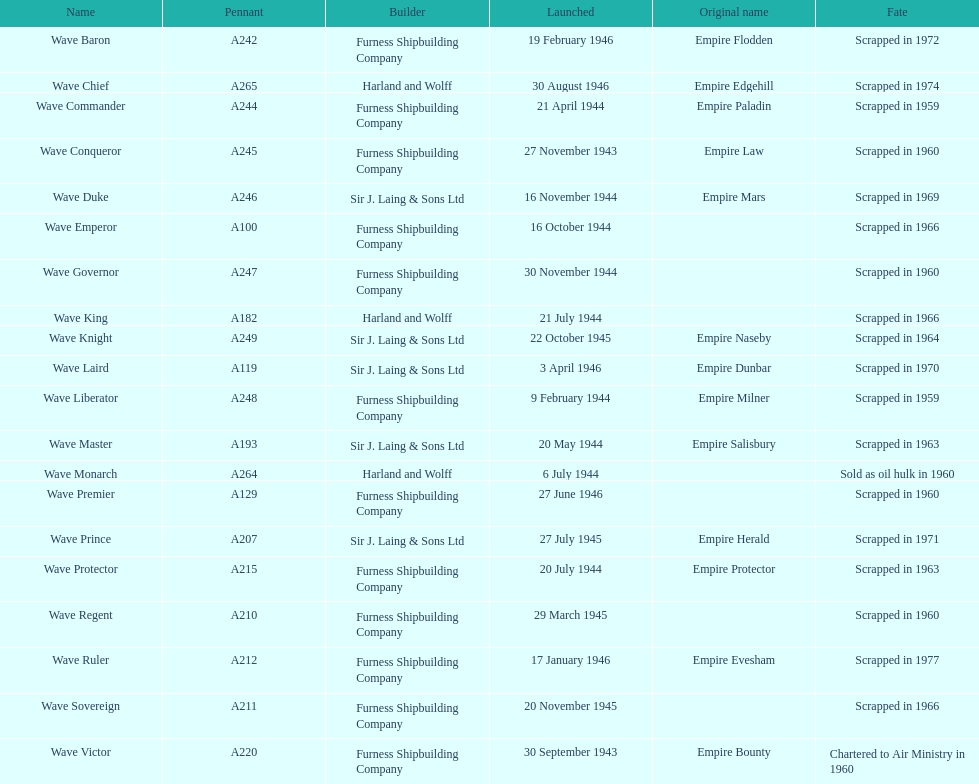Name a builder with "and" in the name. Harland and Wolff. 